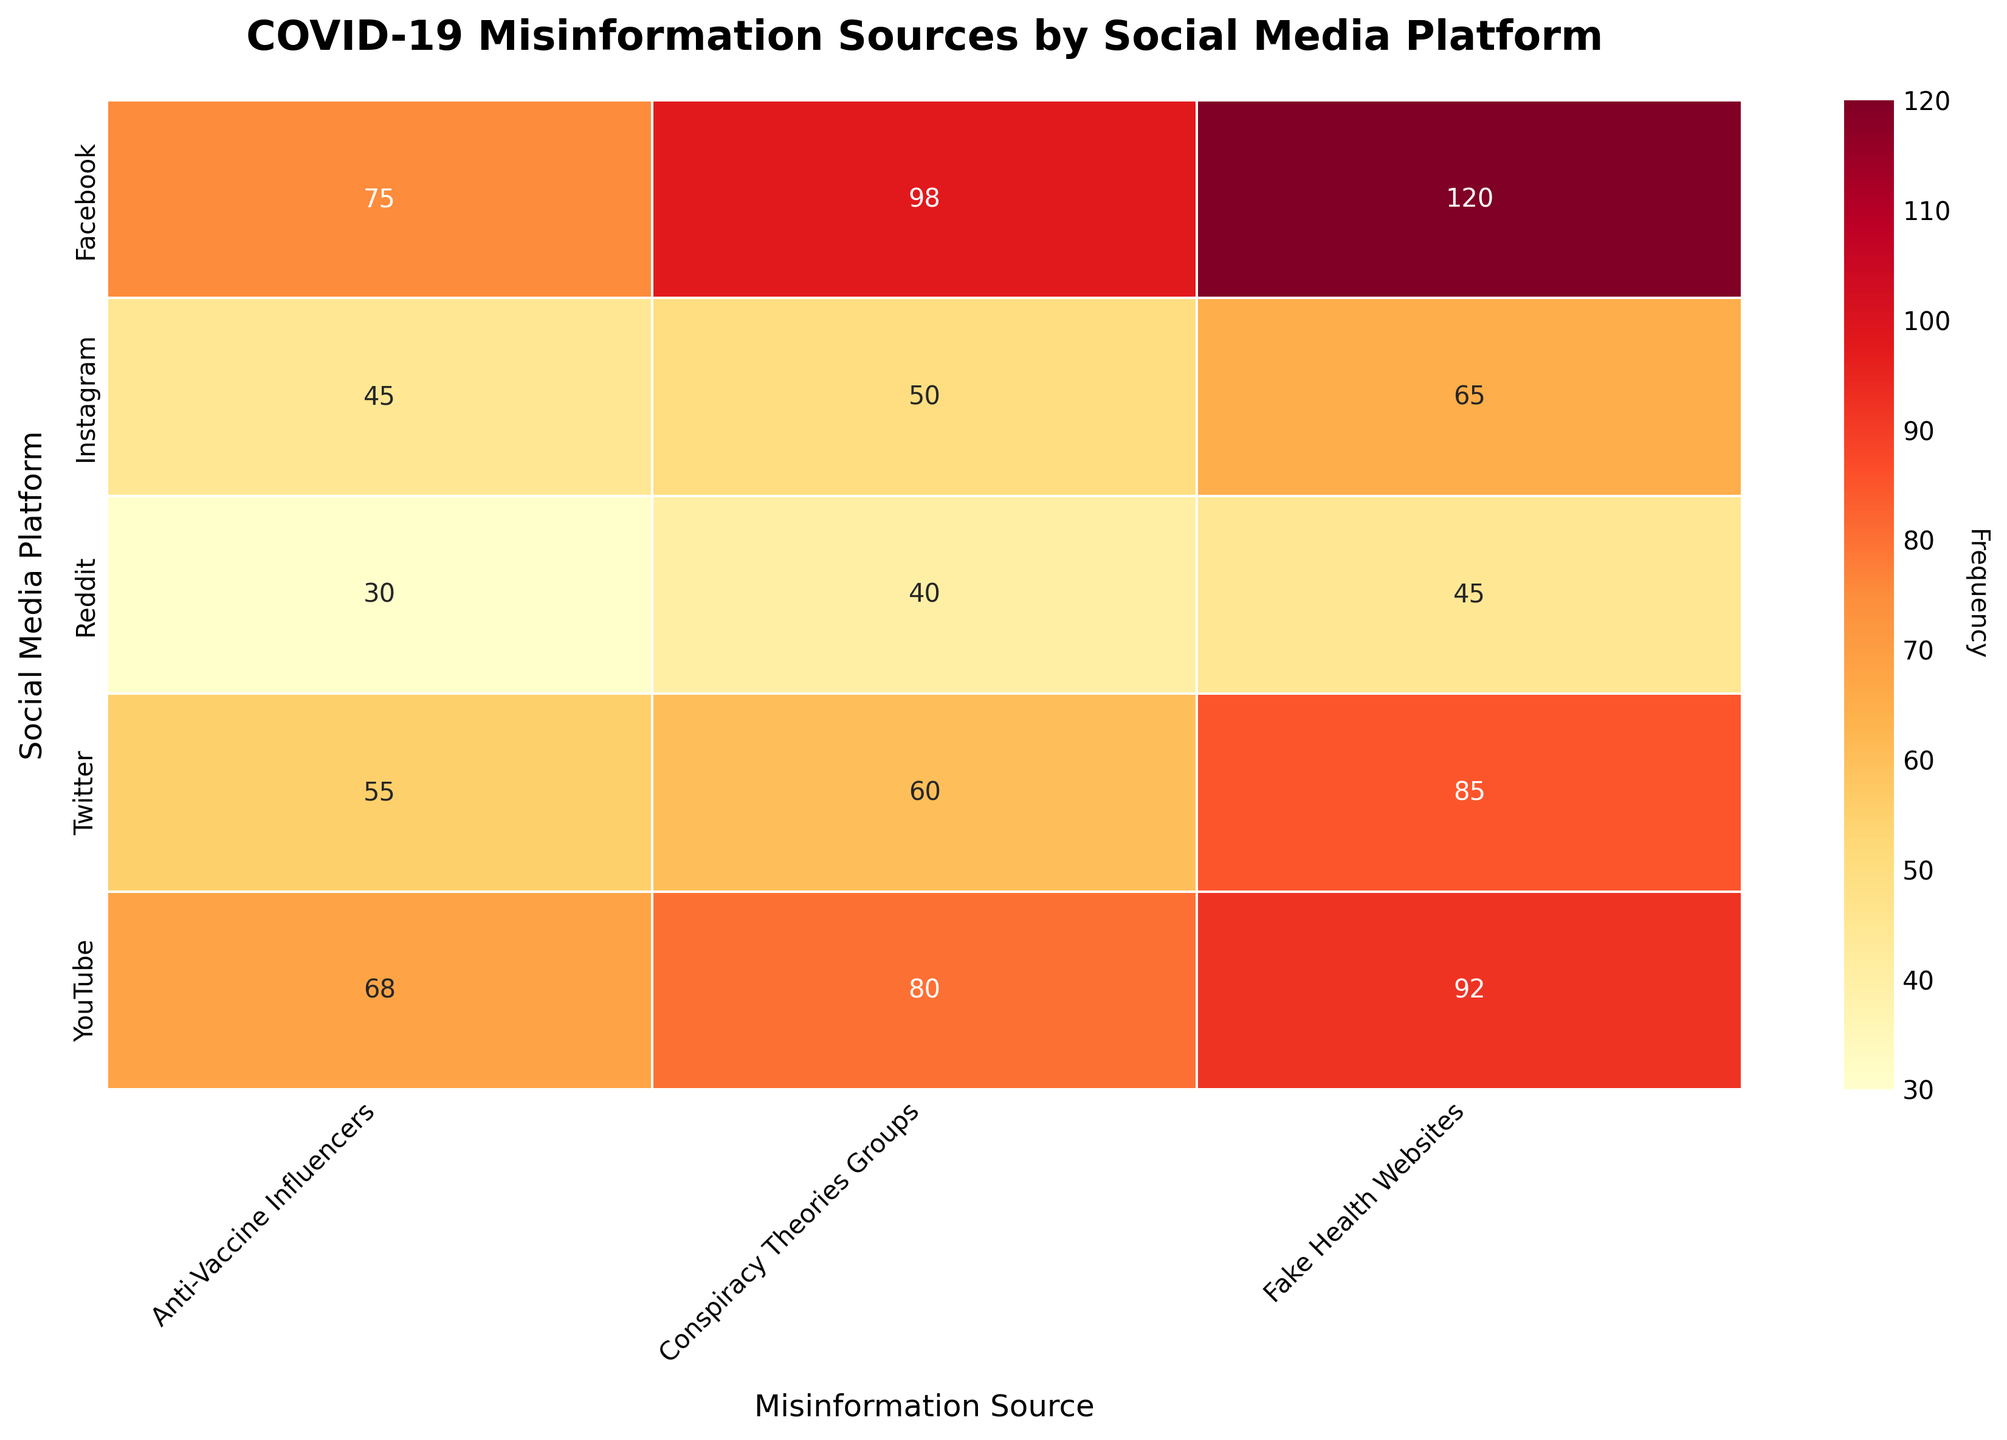What is the highest frequency of misinformation sources on Facebook? Look for the cell with the highest value in the "Facebook" row. The highest value in the Facebook row is 120, from the "Fake Health Websites" column.
Answer: 120 Which social media platform has the least frequency of misinformation from Anti-Vaccine Influencers? Look for the lowest value in the "Anti-Vaccine Influencers" column. The lowest value is 30, in the "Reddit" row.
Answer: Reddit What is the total frequency of misinformation sources for Twitter? Sum the frequencies in the "Twitter" row: 85 (Fake Health Websites) + 60 (Conspiracy Theories Groups) + 55 (Anti-Vaccine Influencers) = 200.
Answer: 200 Is the frequency of misinformation from Fake Health Websites on YouTube greater than on Twitter? Compare the values for "Fake Health Websites" in the "YouTube" and "Twitter" rows. YouTube has 92 and Twitter has 85, so 92 is greater than 85.
Answer: Yes Which misinformation source has the most occurrences on Instagram? Look for the maximum value in the "Instagram" row. The highest value in the Instagram row is 65, from the "Fake Health Websites" column.
Answer: Fake Health Websites Compare the frequency of misinformation from Conspiracy Theories Groups between Facebook and Reddit. Look at the "Conspiracy Theories Groups" column and compare the values in the "Facebook" and "Reddit" rows. Facebook has 98 and Reddit has 40.
Answer: Facebook has more How does the frequency of Anti-Vaccine Influencers on YouTube compare to Instagram? Look at the values in the "Anti-Vaccine Influencers" column for both YouTube and Instagram. YouTube has 68 and Instagram has 45, so YouTube has a higher frequency.
Answer: YouTube is higher Which source of misinformation has the highest frequency overall? Find the maximum value in the entire heatmap. The highest value is 120, under "Fake Health Websites" on Facebook.
Answer: Fake Health Websites on Facebook How many platforms have a frequency of at least 60 for Conspiracy Theories Groups? Look at the "Conspiracy Theories Groups" column and count the number of rows with values 60 or higher. Facebook (98), Twitter (60), and YouTube (80) meet the criteria, so there are 3 platforms.
Answer: 3 platforms 